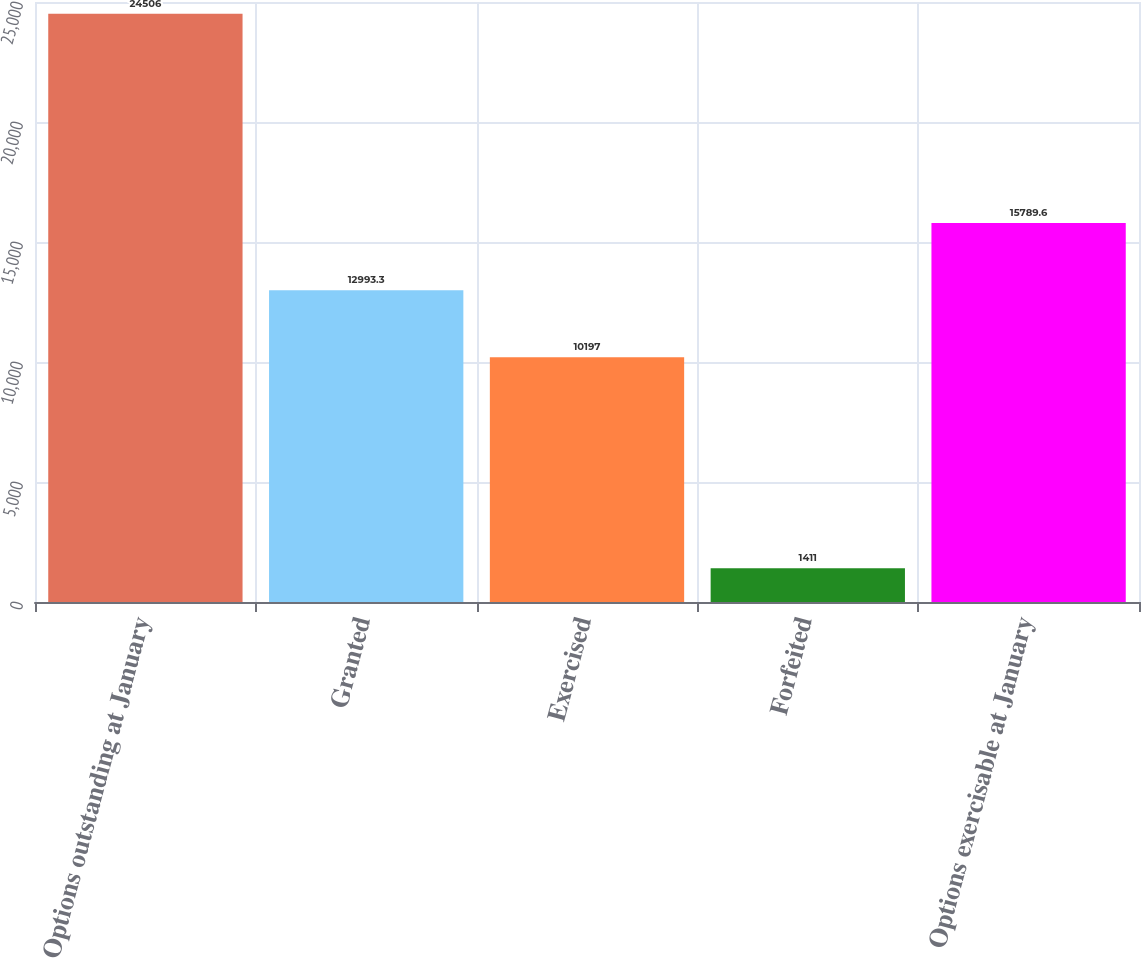Convert chart. <chart><loc_0><loc_0><loc_500><loc_500><bar_chart><fcel>Options outstanding at January<fcel>Granted<fcel>Exercised<fcel>Forfeited<fcel>Options exercisable at January<nl><fcel>24506<fcel>12993.3<fcel>10197<fcel>1411<fcel>15789.6<nl></chart> 